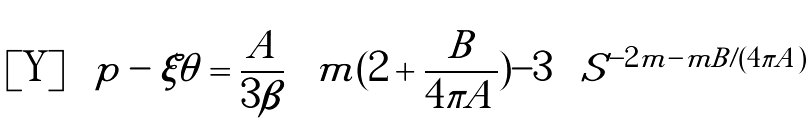Convert formula to latex. <formula><loc_0><loc_0><loc_500><loc_500>p - \xi \theta = \frac { A } { 3 \beta } \left [ m ( 2 + \frac { B } { 4 \pi A } ) - 3 \right ] S ^ { - 2 m - m B / ( 4 \pi A ) }</formula> 